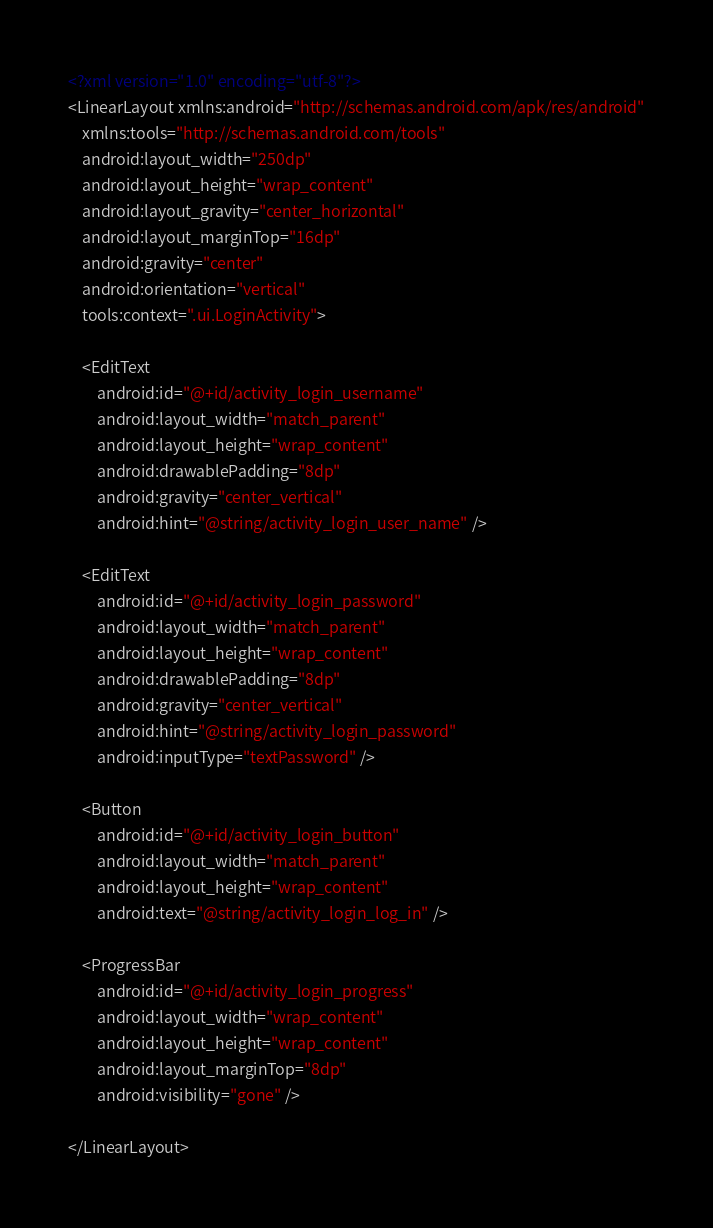Convert code to text. <code><loc_0><loc_0><loc_500><loc_500><_XML_><?xml version="1.0" encoding="utf-8"?>
<LinearLayout xmlns:android="http://schemas.android.com/apk/res/android"
    xmlns:tools="http://schemas.android.com/tools"
    android:layout_width="250dp"
    android:layout_height="wrap_content"
    android:layout_gravity="center_horizontal"
    android:layout_marginTop="16dp"
    android:gravity="center"
    android:orientation="vertical"
    tools:context=".ui.LoginActivity">

    <EditText
        android:id="@+id/activity_login_username"
        android:layout_width="match_parent"
        android:layout_height="wrap_content"
        android:drawablePadding="8dp"
        android:gravity="center_vertical"
        android:hint="@string/activity_login_user_name" />

    <EditText
        android:id="@+id/activity_login_password"
        android:layout_width="match_parent"
        android:layout_height="wrap_content"
        android:drawablePadding="8dp"
        android:gravity="center_vertical"
        android:hint="@string/activity_login_password"
        android:inputType="textPassword" />

    <Button
        android:id="@+id/activity_login_button"
        android:layout_width="match_parent"
        android:layout_height="wrap_content"
        android:text="@string/activity_login_log_in" />

    <ProgressBar
        android:id="@+id/activity_login_progress"
        android:layout_width="wrap_content"
        android:layout_height="wrap_content"
        android:layout_marginTop="8dp"
        android:visibility="gone" />

</LinearLayout>
</code> 